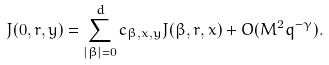Convert formula to latex. <formula><loc_0><loc_0><loc_500><loc_500>J ( 0 , r , y ) = \sum _ { | \beta | = 0 } ^ { d } c _ { \beta , x , y } J ( \beta , r , x ) + O ( M ^ { 2 } q ^ { - \gamma } ) .</formula> 